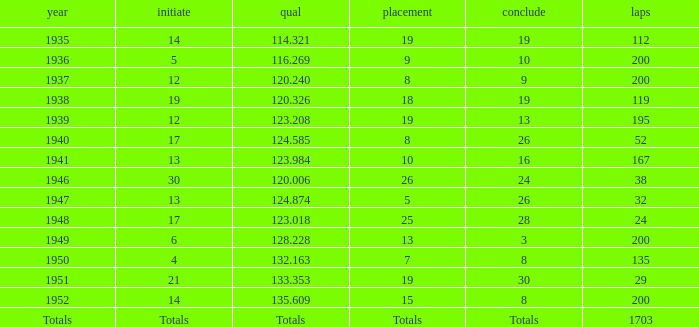The Qual of 120.006 took place in what year? 1946.0. 